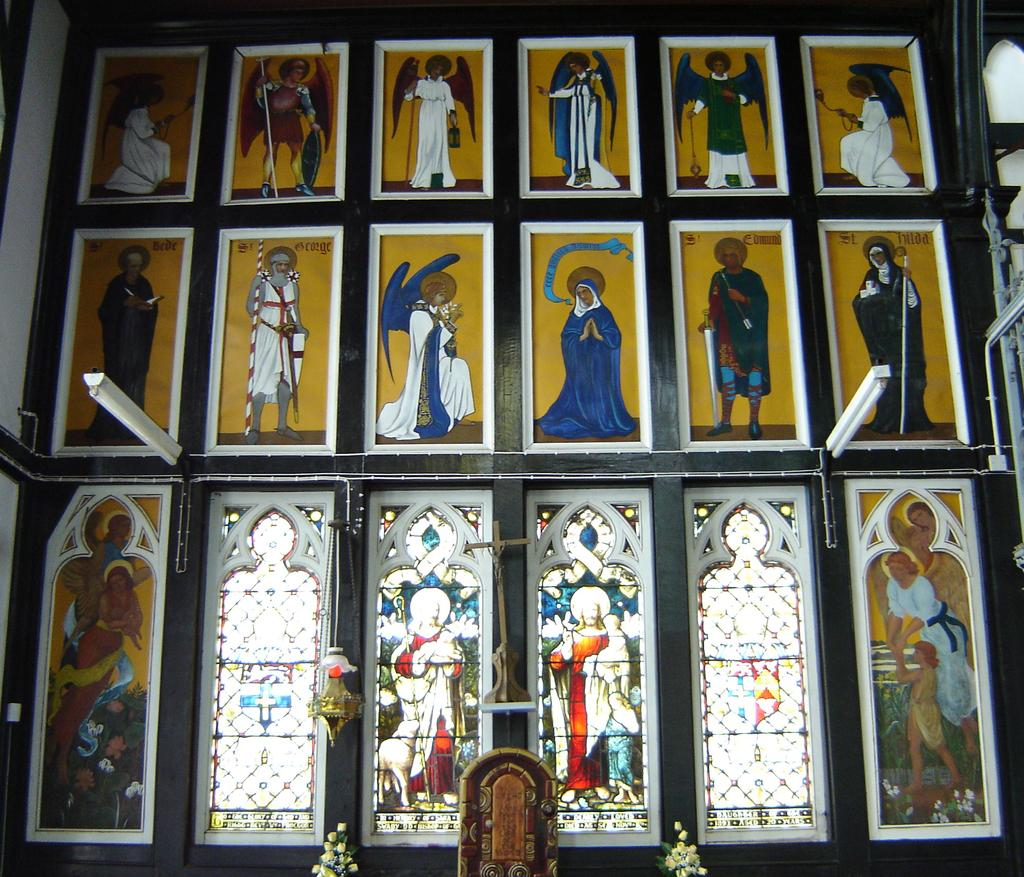What is present on the wall in the image? There is a wall in the image with photo frames, glass windows, and lights on it. Can you describe the photo frames on the wall? The photo frames on the wall contain images or artwork. What type of windows are present on the wall? The windows on the wall are made of glass. How are the lights on the wall providing illumination? The lights on the wall are likely providing artificial light for the room. What type of insurance policy is mentioned in the photo frames on the wall? There is no mention of insurance policies in the photo frames on the wall; they contain images or artwork. 